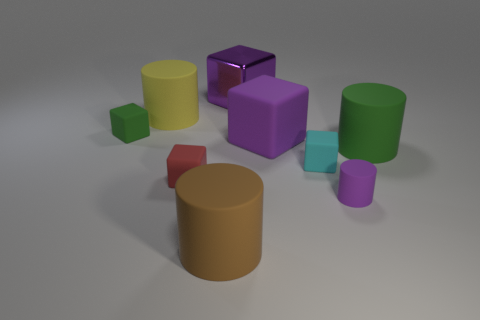Is the color of the tiny object that is in front of the red matte thing the same as the big rubber cube?
Provide a succinct answer. Yes. What is the size of the green thing on the left side of the purple object that is in front of the green object right of the tiny red thing?
Offer a terse response. Small. What number of large matte cylinders are right of the big brown matte cylinder?
Offer a very short reply. 1. Are there more metal blocks than green rubber balls?
Provide a short and direct response. Yes. There is a cylinder that is the same color as the large metallic cube; what size is it?
Your response must be concise. Small. What size is the matte object that is in front of the cyan rubber cube and to the right of the tiny cyan matte block?
Make the answer very short. Small. What is the material of the purple block that is behind the big cylinder behind the big rubber cylinder that is to the right of the big metallic thing?
Your answer should be compact. Metal. There is another block that is the same color as the big matte block; what is it made of?
Make the answer very short. Metal. Is the color of the small thing that is behind the tiny cyan matte object the same as the large matte cylinder that is to the right of the large purple metal object?
Make the answer very short. Yes. The green thing behind the large purple object in front of the purple cube behind the green matte cube is what shape?
Your response must be concise. Cube. 